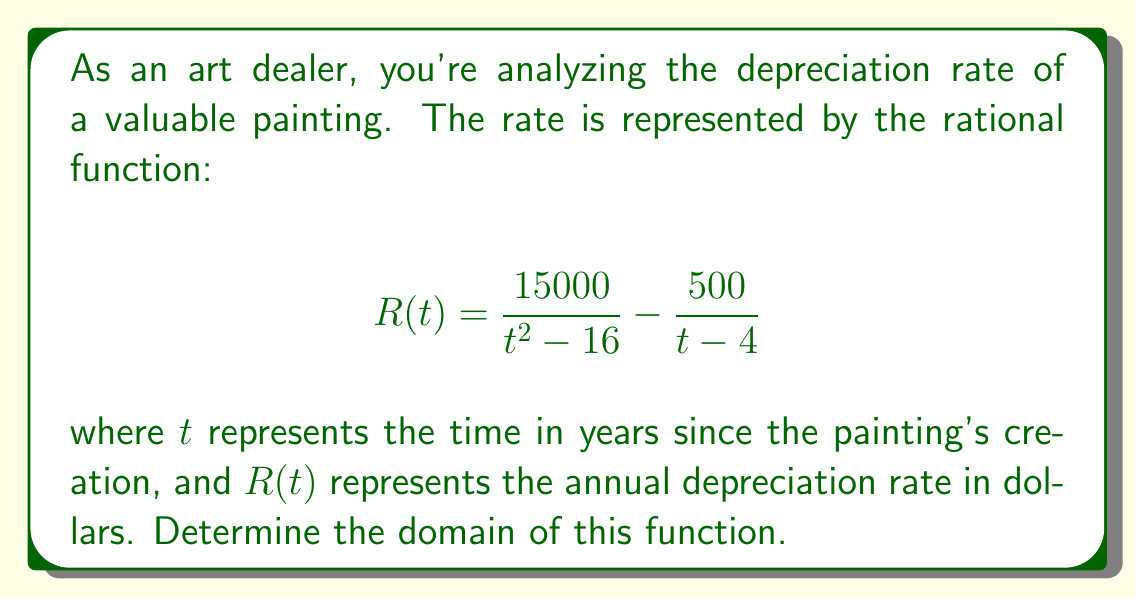Show me your answer to this math problem. To find the domain of this rational function, we need to consider the restrictions on the denominator of each fraction:

1. For the first fraction $\frac{15000}{t^2 - 16}$:
   The denominator cannot be zero, so:
   $t^2 - 16 \neq 0$
   $t^2 \neq 16$
   $t \neq \pm 4$

2. For the second fraction $\frac{500}{t - 4}$:
   The denominator cannot be zero, so:
   $t - 4 \neq 0$
   $t \neq 4$

3. Combining these restrictions:
   $t$ cannot be 4 or -4

4. Therefore, the domain is all real numbers except for 4 and -4.

In set notation, this can be written as:
$\{t \in \mathbb{R} : t \neq 4 \text{ and } t \neq -4\}$

Or in interval notation:
$(-\infty, -4) \cup (-4, 4) \cup (4, \infty)$
Answer: $(-\infty, -4) \cup (-4, 4) \cup (4, \infty)$ 